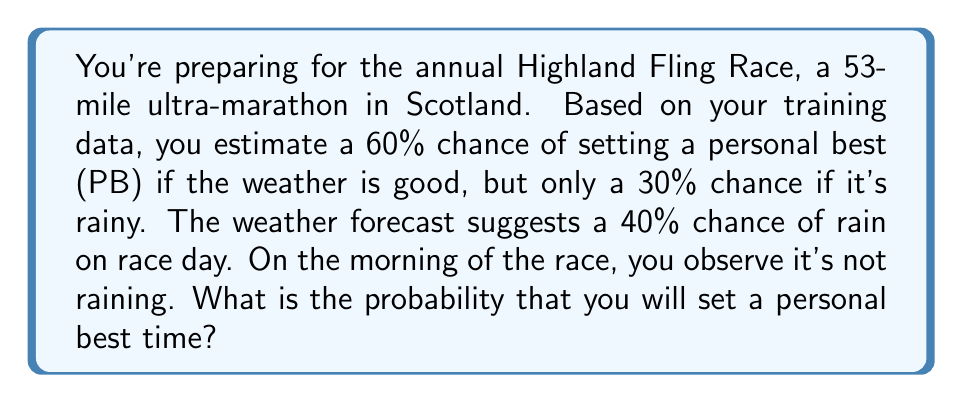Help me with this question. Let's approach this problem using Bayesian inference:

1) Define our events:
   A: Setting a personal best
   B: No rain on race day

2) Given probabilities:
   P(A|Good Weather) = 0.60
   P(A|Rainy) = 0.30
   P(Rainy) = 0.40
   P(Good Weather) = 1 - P(Rainy) = 0.60

3) We want to find P(A|B), the probability of setting a PB given no rain.

4) Using Bayes' Theorem:

   $$P(A|B) = \frac{P(B|A)P(A)}{P(B)}$$

5) We need to calculate P(B|A), P(A), and P(B):

   P(A) = P(A|Good Weather)P(Good Weather) + P(A|Rainy)P(Rainy)
        = 0.60 * 0.60 + 0.30 * 0.40 = 0.48

   P(B) = P(Good Weather) = 0.60

   P(B|A) = P(Good Weather|A) 
          = \frac{P(A|Good Weather)P(Good Weather)}{P(A)}
          = \frac{0.60 * 0.60}{0.48} = 0.75

6) Now we can apply Bayes' Theorem:

   $$P(A|B) = \frac{0.75 * 0.48}{0.60} = 0.60$$

Therefore, given that it's not raining on race day, the probability of setting a personal best is 0.60 or 60%.
Answer: 0.60 